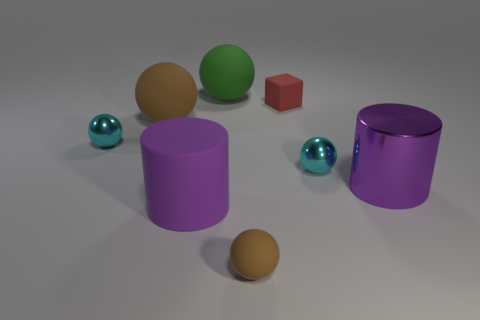What color is the small matte thing that is behind the metal cylinder?
Ensure brevity in your answer.  Red. There is a tiny cyan thing that is right of the purple object in front of the purple shiny thing; what shape is it?
Provide a short and direct response. Sphere. Is the color of the large shiny object the same as the rubber cylinder?
Ensure brevity in your answer.  Yes. How many cylinders are cyan metal objects or large things?
Give a very brief answer. 2. What is the material of the object that is behind the large brown matte ball and on the right side of the tiny brown matte sphere?
Provide a short and direct response. Rubber. What number of large brown rubber balls are behind the small red rubber thing?
Offer a terse response. 0. Is the material of the tiny cyan object that is to the left of the red thing the same as the purple object that is on the right side of the small brown matte sphere?
Your response must be concise. Yes. How many objects are either purple things on the left side of the purple metallic object or purple things?
Your answer should be very brief. 2. Are there fewer brown spheres that are on the left side of the small brown rubber sphere than balls that are behind the large shiny cylinder?
Make the answer very short. Yes. What number of other things are there of the same size as the red rubber cube?
Your response must be concise. 3. 